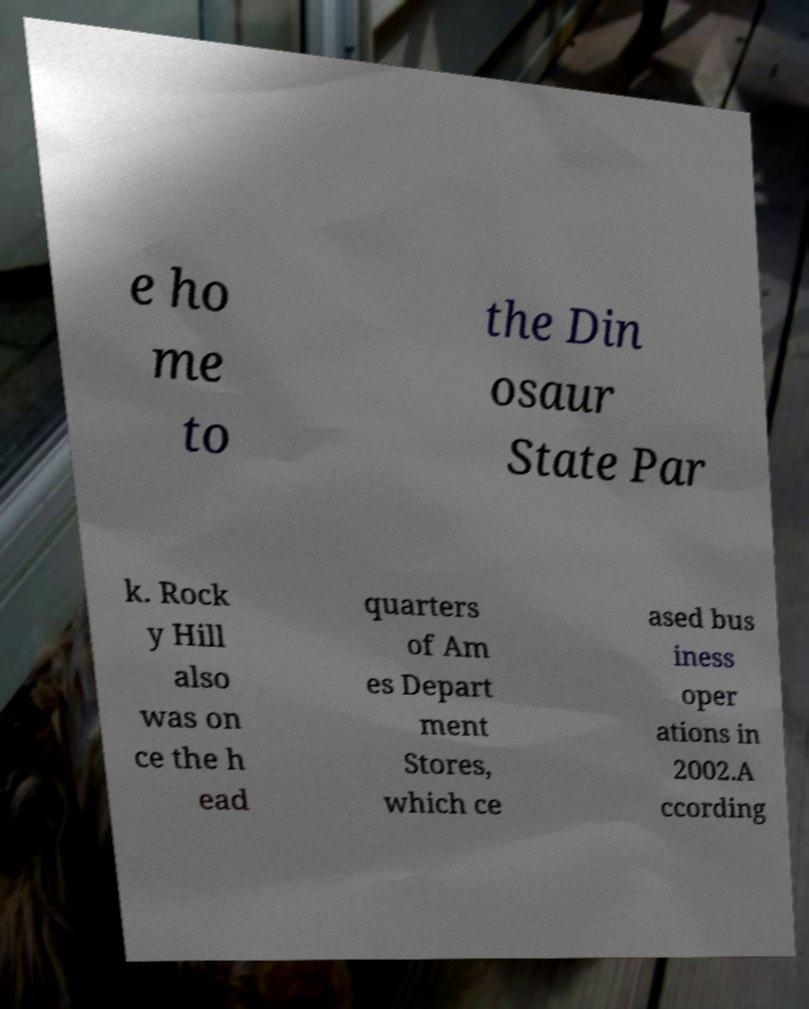Please read and relay the text visible in this image. What does it say? e ho me to the Din osaur State Par k. Rock y Hill also was on ce the h ead quarters of Am es Depart ment Stores, which ce ased bus iness oper ations in 2002.A ccording 